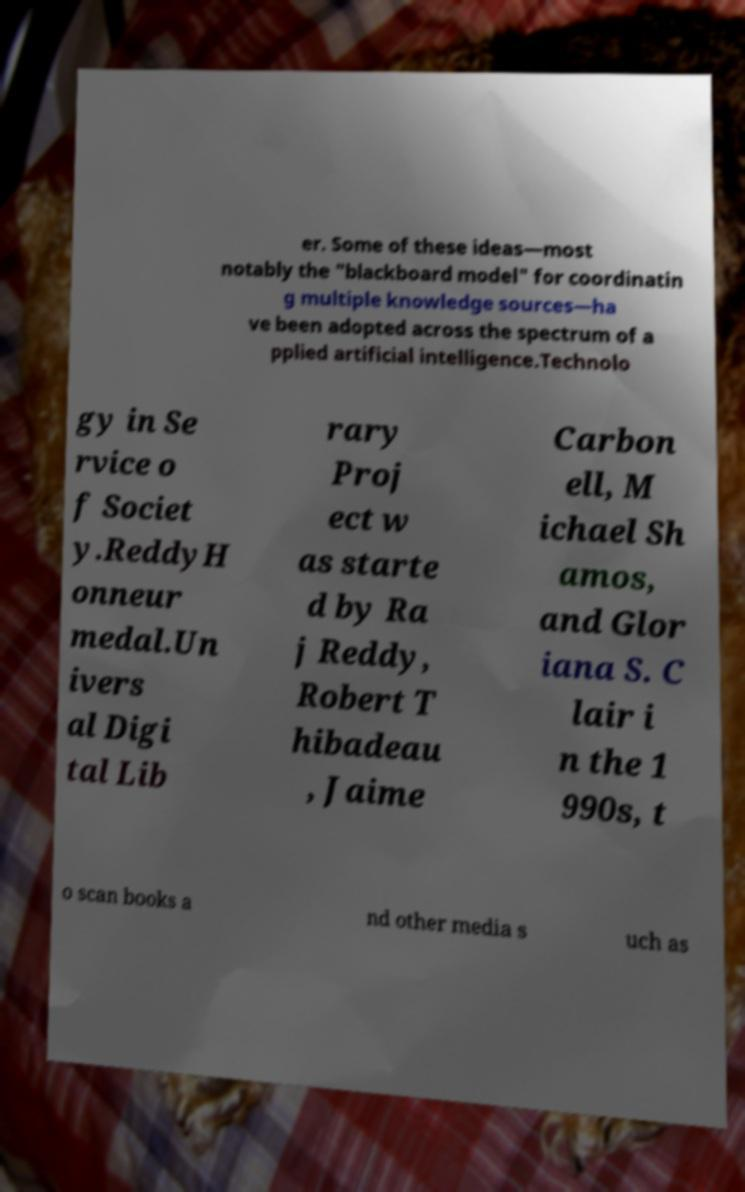What messages or text are displayed in this image? I need them in a readable, typed format. er. Some of these ideas—most notably the "blackboard model" for coordinatin g multiple knowledge sources—ha ve been adopted across the spectrum of a pplied artificial intelligence.Technolo gy in Se rvice o f Societ y.ReddyH onneur medal.Un ivers al Digi tal Lib rary Proj ect w as starte d by Ra j Reddy, Robert T hibadeau , Jaime Carbon ell, M ichael Sh amos, and Glor iana S. C lair i n the 1 990s, t o scan books a nd other media s uch as 